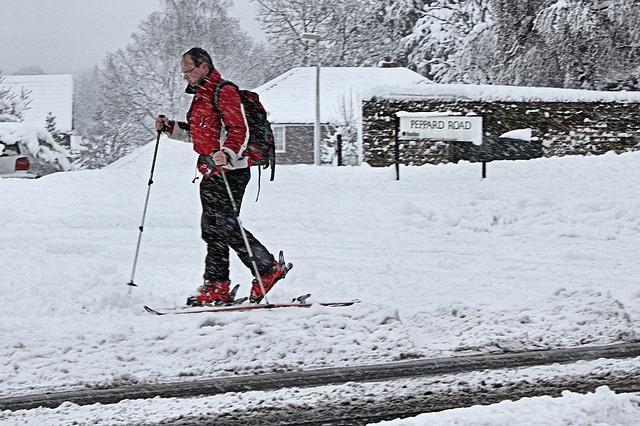What caused the lines in the snow?
Answer the question by selecting the correct answer among the 4 following choices.
Options: Car wheels, skis, animal, shovel. Car wheels. 